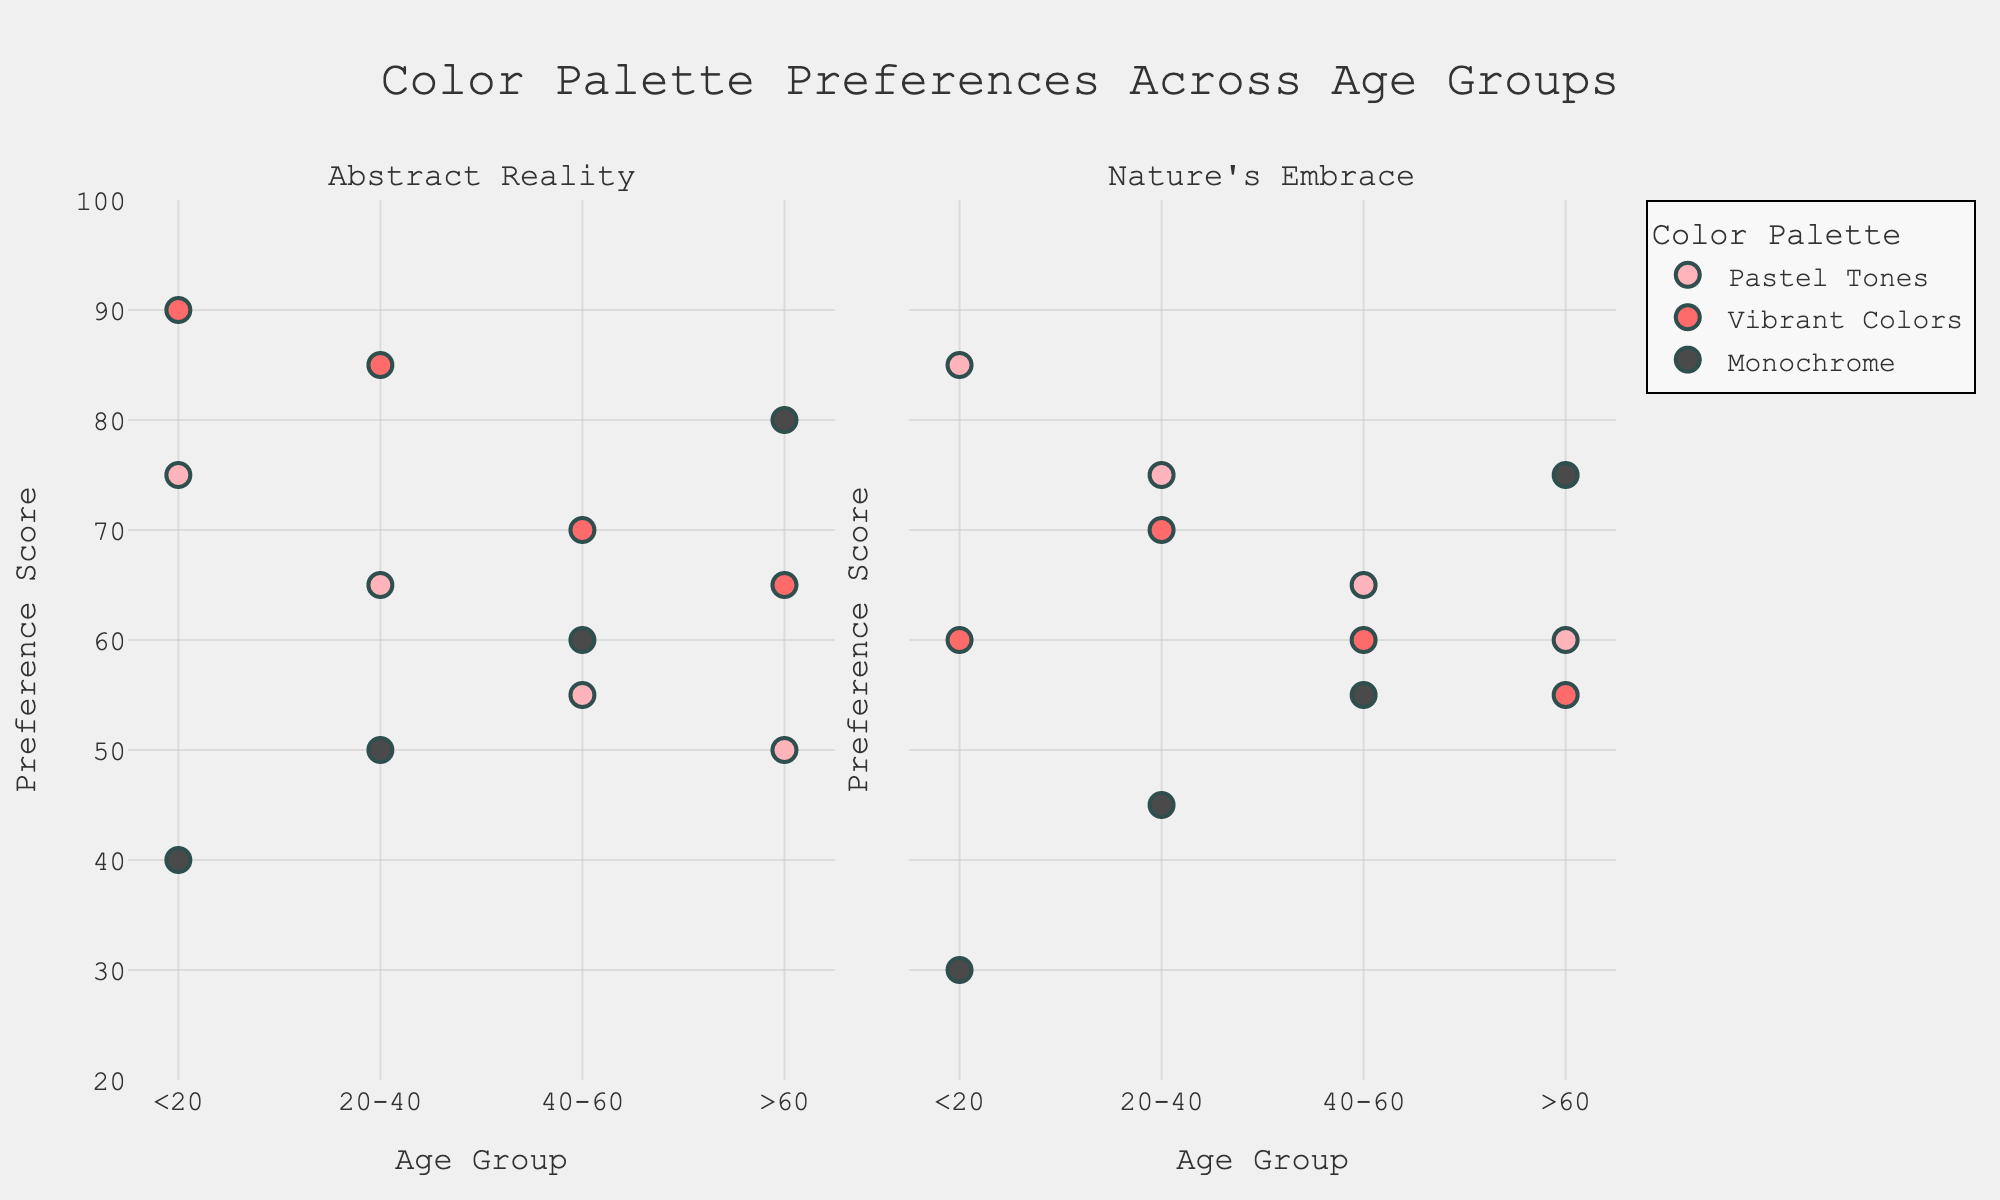How many color palettes are showcased in the "Abstract Reality" exhibition? By looking at the first subplot titled "Abstract Reality", observe the legend to identify the color palettes. There are three color palettes: Pastel Tones, Vibrant Colors, and Monochrome.
Answer: 3 Which age group shows the highest preference for Vibrant Colors in the "Nature's Embrace" exhibition? In the second subplot titled "Nature's Embrace", locate the markers representing Vibrant Colors. The highest marker is at 75 for the <20 age group.
Answer: <20 What is the overall trend in preference for Monochrome across all age groups in both exhibitions? Look at both subplots and observe the markers for Monochrome. In "Abstract Reality", preference increases with age. In "Nature's Embrace", it slightly increases, peaks at 75 for >60. Overall, preference for Monochrome generally increases with age.
Answer: Increases with age Compare the preference scores for Pastel Tones across all age groups in "Nature's Embrace". Which age group prefers it the most? In the second subplot titled "Nature's Embrace", locate the markers for Pastel Tones across all age groups. The highest marker is at 85 for the <20 age group.
Answer: <20 What is the difference in preference scores for Pastel Tones between the <20 and >60 age groups in the "Abstract Reality" exhibition? In the first subplot titled "Abstract Reality", locate the Pastel Tones markers for <20 and >60 age groups. The preference scores are 75 and 50 respectively. The difference is 75 - 50 = 25.
Answer: 25 Which age group has the most varied preferences for different color palettes in the "Abstract Reality" exhibition? In the first subplot titled "Abstract Reality", observe the spread of markers within each age group. The <20 age group has the most varied preferences with scores of 75, 90, and 40 for different palettes.
Answer: <20 What is the average preference score for the 20-40 age group in the "Nature's Embrace" exhibition? In the second subplot titled "Nature's Embrace", locate the markers for the 20-40 age group. The scores are 75, 70, and 45. Calculate the average: (75 + 70 + 45) / 3 = 63.33
Answer: 63.33 How do preferences for Vibrant Colors vary between the "Abstract Reality" and "Nature's Embrace" exhibitions for the 40-60 age group? Compare the markers for Vibrant Colors in the 40-60 age group in both subplots. In "Abstract Reality", it is 70, and in "Nature's Embrace", it is 60. Preferences are higher in "Abstract Reality".
Answer: Higher in "Abstract Reality" Do the preference scores for Monochrome in the >60 age group differ significantly between the two exhibitions? Examine the markers for Monochrome in the >60 age group across both subplots. The scores are 80 in "Abstract Reality" and 75 in "Nature's Embrace." The difference is minimal.
Answer: No significant difference 